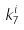Convert formula to latex. <formula><loc_0><loc_0><loc_500><loc_500>k _ { 7 } ^ { i }</formula> 